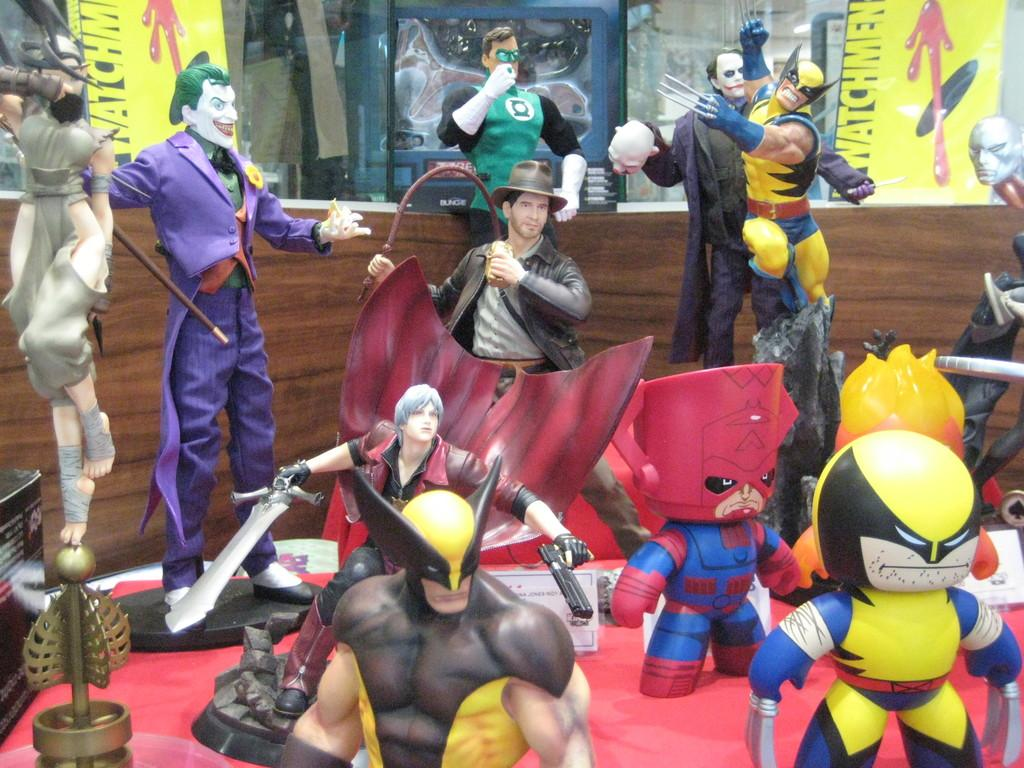What types of objects are present in the image? There are different toys in the image. Where are the toys located in the image? The toys are located in the middle of the image. What type of police officer is visible in the image? There is no police officer present in the image; it only features different toys. How many dimes can be seen scattered among the toys in the image? There are no dimes present in the image; it only features different toys. 